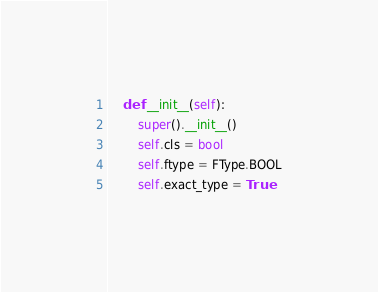<code> <loc_0><loc_0><loc_500><loc_500><_Python_>    def __init__(self):
        super().__init__()
        self.cls = bool
        self.ftype = FType.BOOL
        self.exact_type = True
</code> 